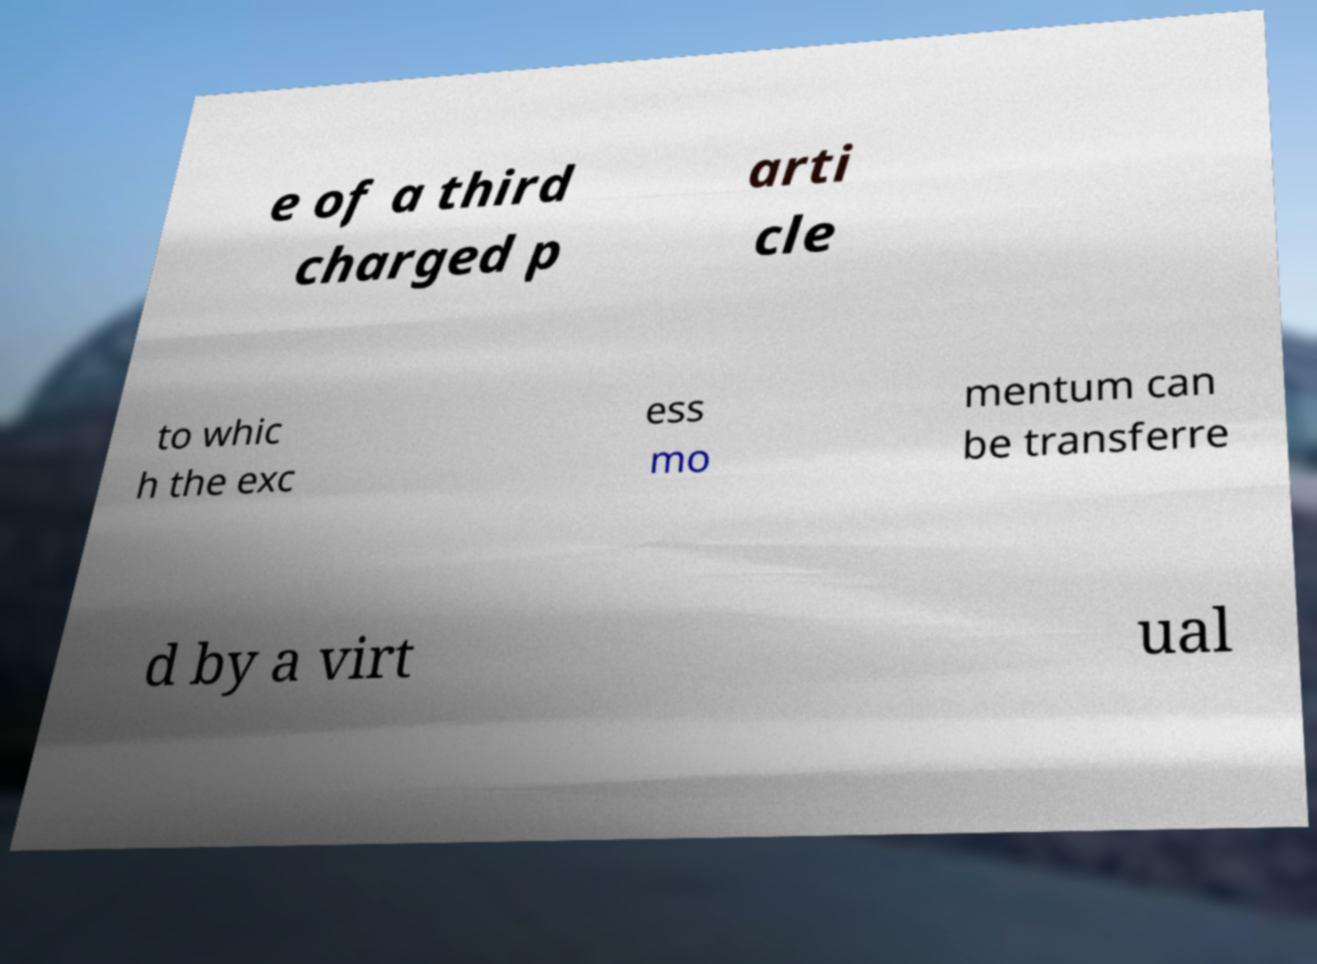Please identify and transcribe the text found in this image. e of a third charged p arti cle to whic h the exc ess mo mentum can be transferre d by a virt ual 